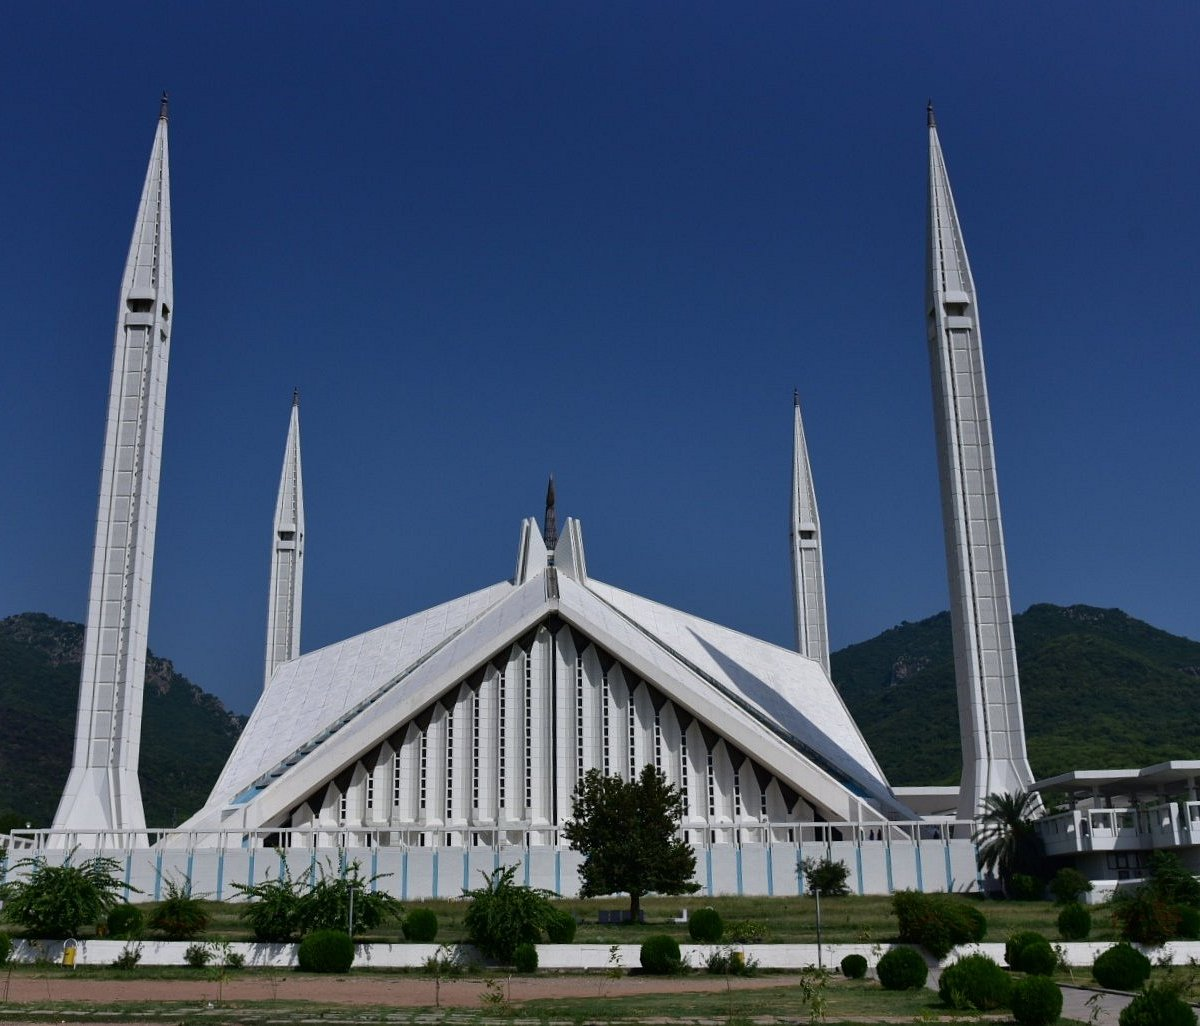Can you explain the architectural design style of Faisal Mosque? The architectural style of Faisal Mosque is decidedly modernist, influenced by both contemporary and traditional Islamic design. Instead of a conventional dome, the mosque features a sloping roof composed of eight sides that converge to a high-center point, echoing a Bedouin tent. This design, created by Turkish architect Vedat Dalokay, was chosen to symbolize unity and the modernization of Islam. Each of the four minarets, indicative of Turkish-style architecture, soars skywards, adding elegance and a prayerful ambiance to the mosque's serene locale. 